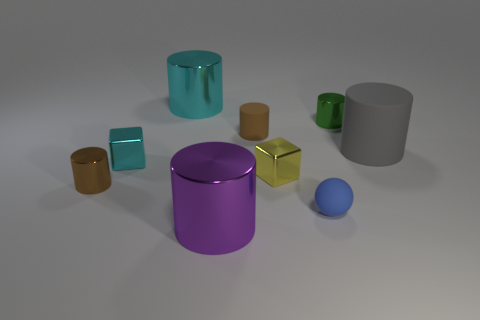Is there anything else of the same color as the tiny rubber sphere?
Give a very brief answer. No. There is a thing right of the metal cylinder right of the blue ball; what is its color?
Offer a very short reply. Gray. The tiny brown object that is to the right of the small shiny cylinder that is on the left side of the small blue matte ball that is left of the green shiny cylinder is made of what material?
Give a very brief answer. Rubber. What number of matte things are the same size as the purple metal cylinder?
Make the answer very short. 1. The cylinder that is both behind the tiny brown matte cylinder and right of the blue sphere is made of what material?
Ensure brevity in your answer.  Metal. There is a big rubber cylinder; what number of small cyan metallic cubes are behind it?
Provide a short and direct response. 0. There is a big purple thing; is its shape the same as the cyan metal object to the left of the cyan metallic cylinder?
Offer a very short reply. No. Is there a large yellow thing that has the same shape as the brown rubber object?
Provide a short and direct response. No. There is a small brown thing that is to the right of the big cylinder that is in front of the tiny yellow metallic cube; what shape is it?
Provide a short and direct response. Cylinder. The tiny brown thing that is on the right side of the large purple shiny thing has what shape?
Your answer should be very brief. Cylinder. 